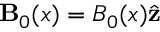Convert formula to latex. <formula><loc_0><loc_0><loc_500><loc_500>B _ { 0 } ( x ) = B _ { 0 } ( x ) \hat { z }</formula> 